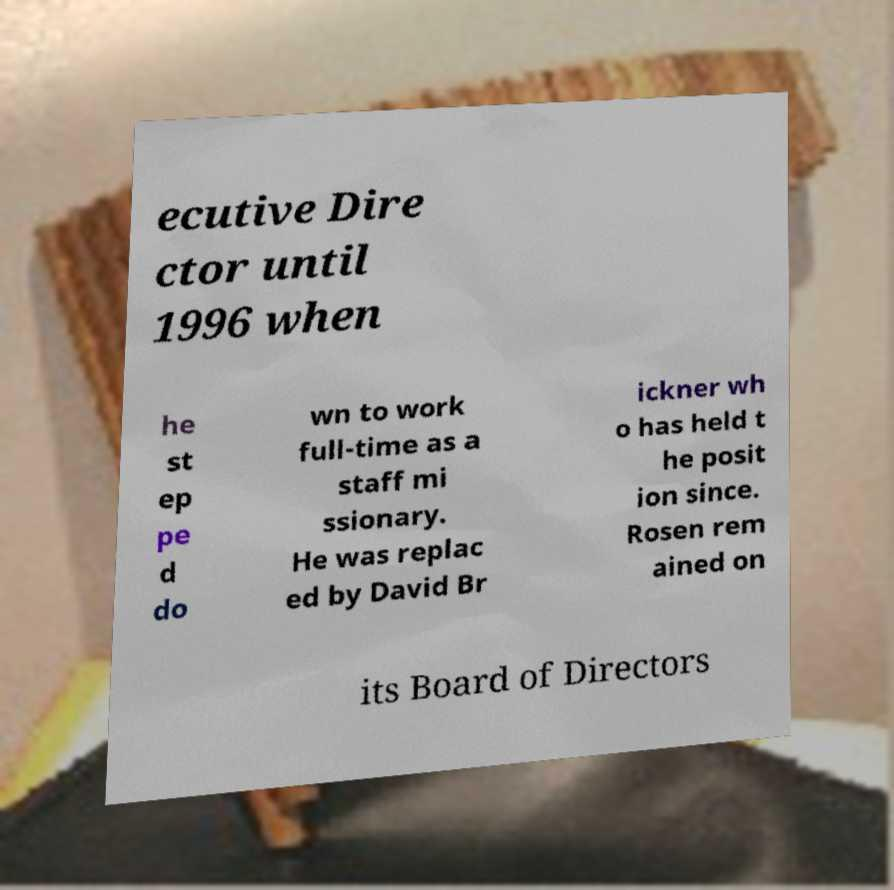Please identify and transcribe the text found in this image. ecutive Dire ctor until 1996 when he st ep pe d do wn to work full-time as a staff mi ssionary. He was replac ed by David Br ickner wh o has held t he posit ion since. Rosen rem ained on its Board of Directors 